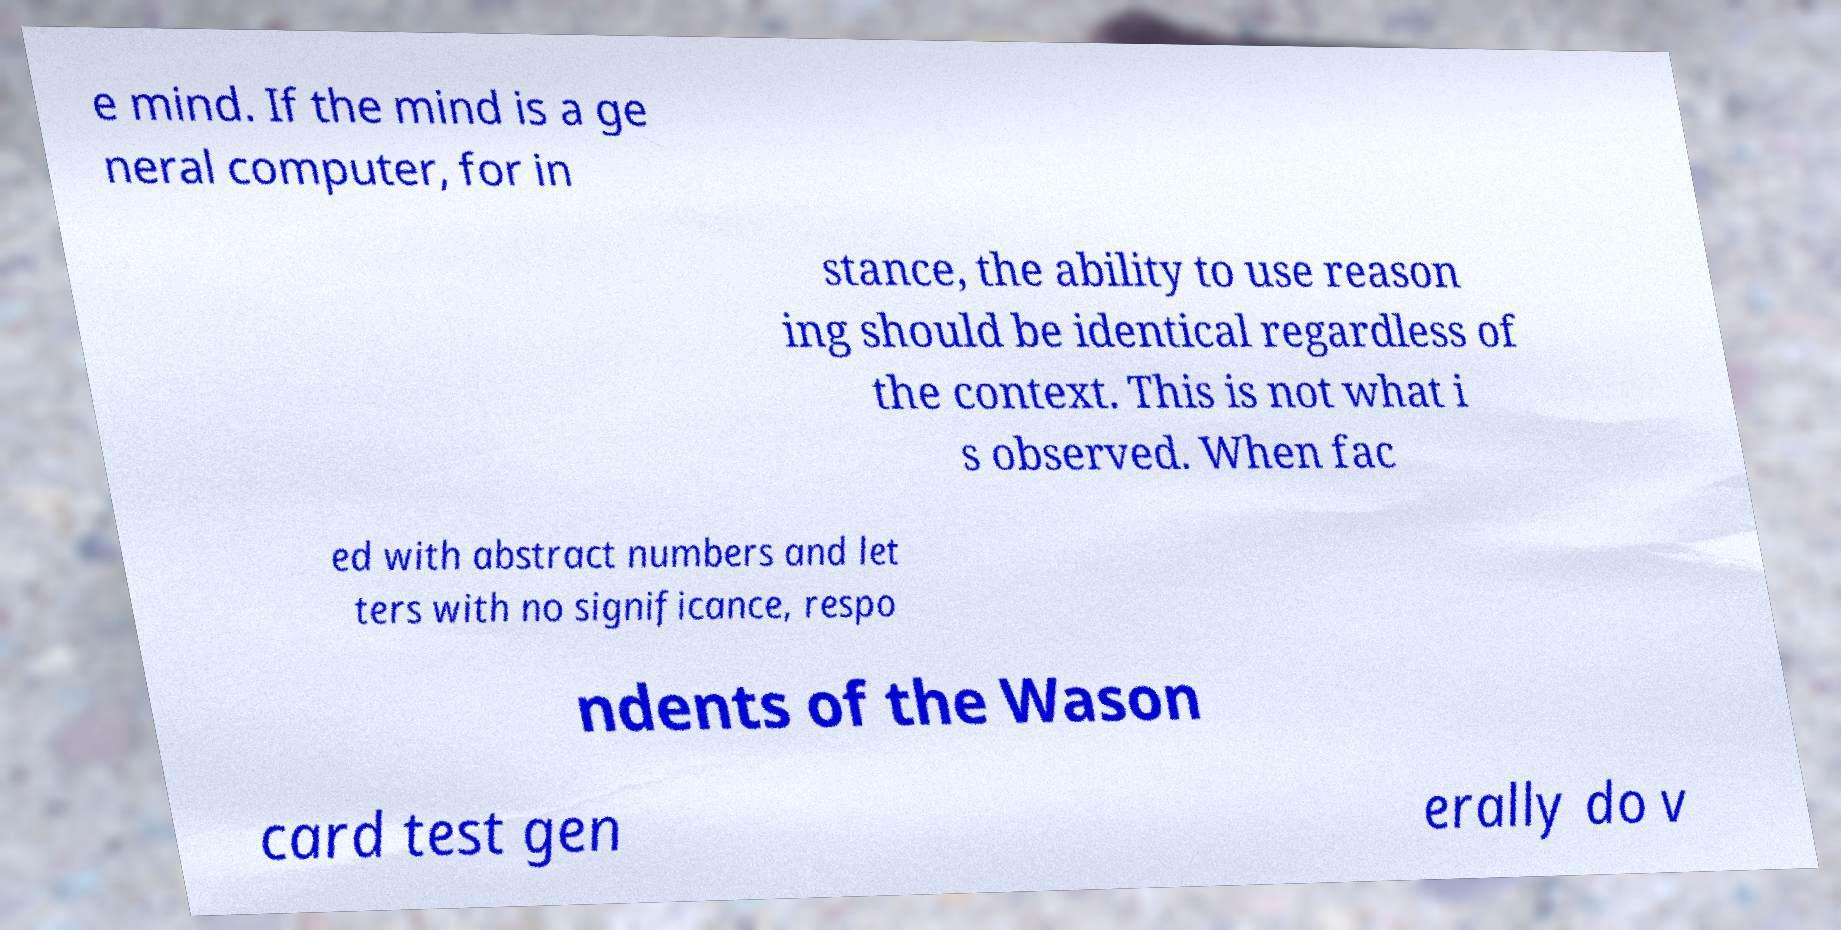Could you extract and type out the text from this image? e mind. If the mind is a ge neral computer, for in stance, the ability to use reason ing should be identical regardless of the context. This is not what i s observed. When fac ed with abstract numbers and let ters with no significance, respo ndents of the Wason card test gen erally do v 